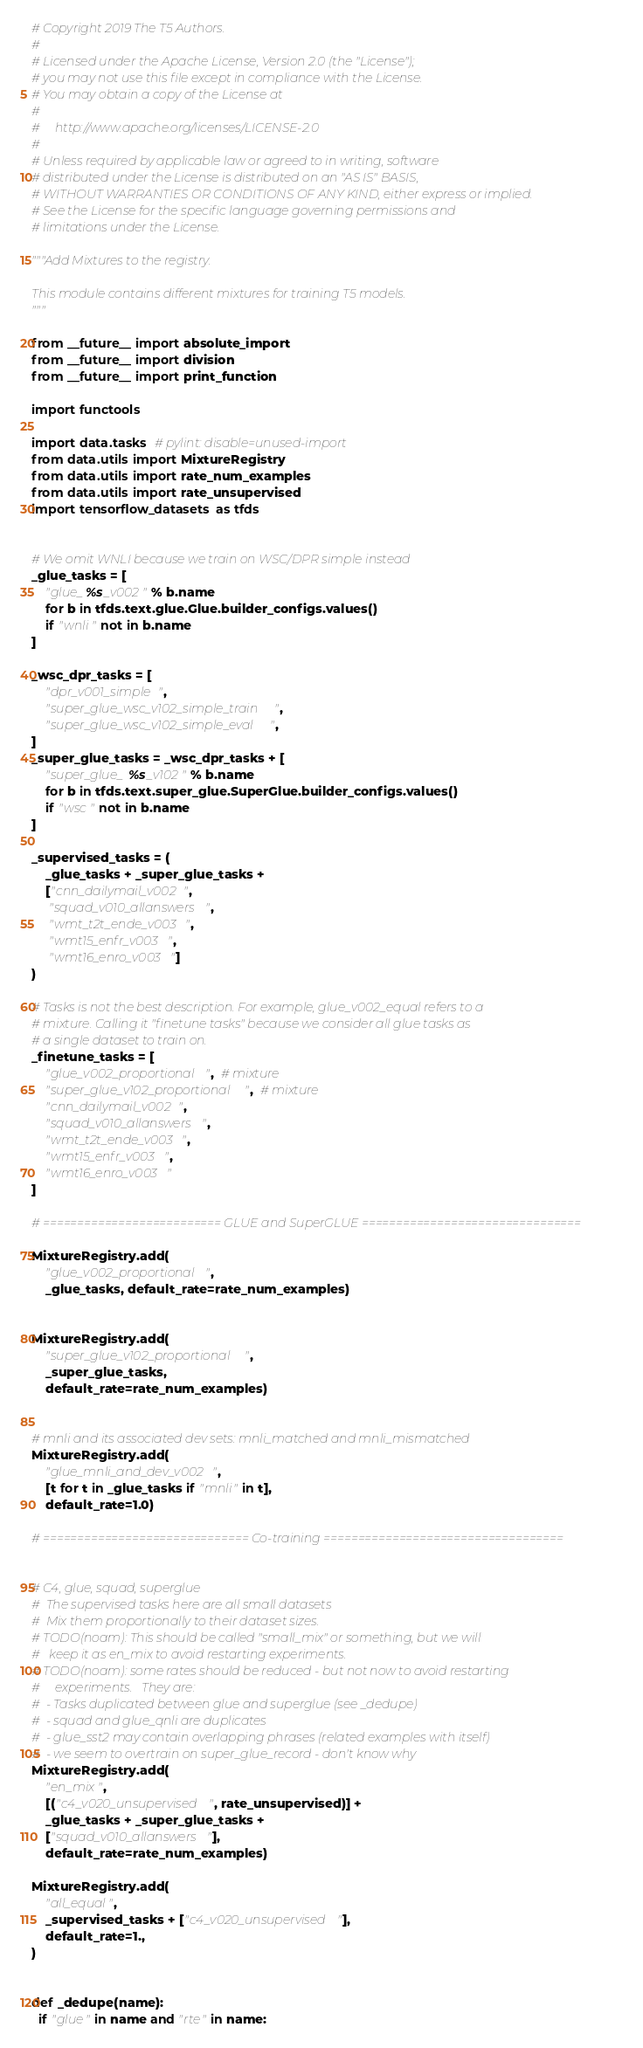Convert code to text. <code><loc_0><loc_0><loc_500><loc_500><_Python_># Copyright 2019 The T5 Authors.
#
# Licensed under the Apache License, Version 2.0 (the "License");
# you may not use this file except in compliance with the License.
# You may obtain a copy of the License at
#
#     http://www.apache.org/licenses/LICENSE-2.0
#
# Unless required by applicable law or agreed to in writing, software
# distributed under the License is distributed on an "AS IS" BASIS,
# WITHOUT WARRANTIES OR CONDITIONS OF ANY KIND, either express or implied.
# See the License for the specific language governing permissions and
# limitations under the License.

"""Add Mixtures to the registry.

This module contains different mixtures for training T5 models.
"""

from __future__ import absolute_import
from __future__ import division
from __future__ import print_function

import functools

import data.tasks  # pylint: disable=unused-import
from data.utils import MixtureRegistry
from data.utils import rate_num_examples
from data.utils import rate_unsupervised
import tensorflow_datasets as tfds


# We omit WNLI because we train on WSC/DPR simple instead
_glue_tasks = [
    "glue_%s_v002" % b.name
    for b in tfds.text.glue.Glue.builder_configs.values()
    if "wnli" not in b.name
]

_wsc_dpr_tasks = [
    "dpr_v001_simple",
    "super_glue_wsc_v102_simple_train",
    "super_glue_wsc_v102_simple_eval",
]
_super_glue_tasks = _wsc_dpr_tasks + [
    "super_glue_%s_v102" % b.name
    for b in tfds.text.super_glue.SuperGlue.builder_configs.values()
    if "wsc" not in b.name
]

_supervised_tasks = (
    _glue_tasks + _super_glue_tasks +
    ["cnn_dailymail_v002",
     "squad_v010_allanswers",
     "wmt_t2t_ende_v003",
     "wmt15_enfr_v003",
     "wmt16_enro_v003"]
)

# Tasks is not the best description. For example, glue_v002_equal refers to a
# mixture. Calling it "finetune tasks" because we consider all glue tasks as
# a single dataset to train on.
_finetune_tasks = [
    "glue_v002_proportional",  # mixture
    "super_glue_v102_proportional",  # mixture
    "cnn_dailymail_v002",
    "squad_v010_allanswers",
    "wmt_t2t_ende_v003",
    "wmt15_enfr_v003",
    "wmt16_enro_v003"
]

# ========================== GLUE and SuperGLUE ================================

MixtureRegistry.add(
    "glue_v002_proportional",
    _glue_tasks, default_rate=rate_num_examples)


MixtureRegistry.add(
    "super_glue_v102_proportional",
    _super_glue_tasks,
    default_rate=rate_num_examples)


# mnli and its associated dev sets: mnli_matched and mnli_mismatched
MixtureRegistry.add(
    "glue_mnli_and_dev_v002",
    [t for t in _glue_tasks if "mnli" in t],
    default_rate=1.0)

# ============================== Co-training ===================================


# C4, glue, squad, superglue
#  The supervised tasks here are all small datasets
#  Mix them proportionally to their dataset sizes.
# TODO(noam): This should be called "small_mix" or something, but we will
#   keep it as en_mix to avoid restarting experiments.
# TODO(noam): some rates should be reduced - but not now to avoid restarting
#     experiments.   They are:
#  - Tasks duplicated between glue and superglue (see _dedupe)
#  - squad and glue_qnli are duplicates
#  - glue_sst2 may contain overlapping phrases (related examples with itself)
#  - we seem to overtrain on super_glue_record - don't know why
MixtureRegistry.add(
    "en_mix",
    [("c4_v020_unsupervised", rate_unsupervised)] +
    _glue_tasks + _super_glue_tasks +
    ["squad_v010_allanswers"],
    default_rate=rate_num_examples)

MixtureRegistry.add(
    "all_equal",
    _supervised_tasks + ["c4_v020_unsupervised"],
    default_rate=1.,
)


def _dedupe(name):
  if "glue" in name and "rte" in name:</code> 